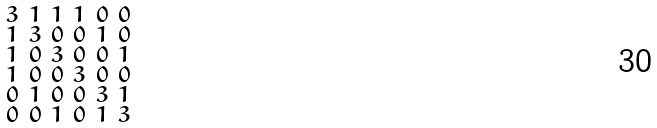<formula> <loc_0><loc_0><loc_500><loc_500>\begin{smallmatrix} 3 & 1 & 1 & 1 & 0 & 0 \\ 1 & 3 & 0 & 0 & 1 & 0 \\ 1 & 0 & 3 & 0 & 0 & 1 \\ 1 & 0 & 0 & 3 & 0 & 0 \\ 0 & 1 & 0 & 0 & 3 & 1 \\ 0 & 0 & 1 & 0 & 1 & 3 \end{smallmatrix}</formula> 